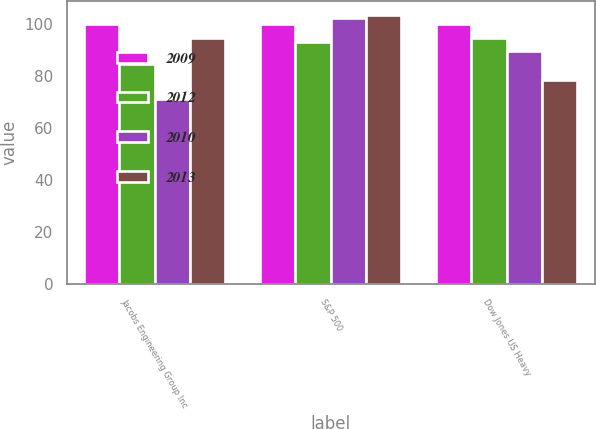<chart> <loc_0><loc_0><loc_500><loc_500><stacked_bar_chart><ecel><fcel>Jacobs Engineering Group Inc<fcel>S&P 500<fcel>Dow Jones US Heavy<nl><fcel>2009<fcel>100<fcel>100<fcel>100<nl><fcel>2012<fcel>84.61<fcel>93.09<fcel>94.87<nl><fcel>2010<fcel>71.26<fcel>102.55<fcel>89.69<nl><fcel>2013<fcel>94.87<fcel>103.72<fcel>78.46<nl></chart> 